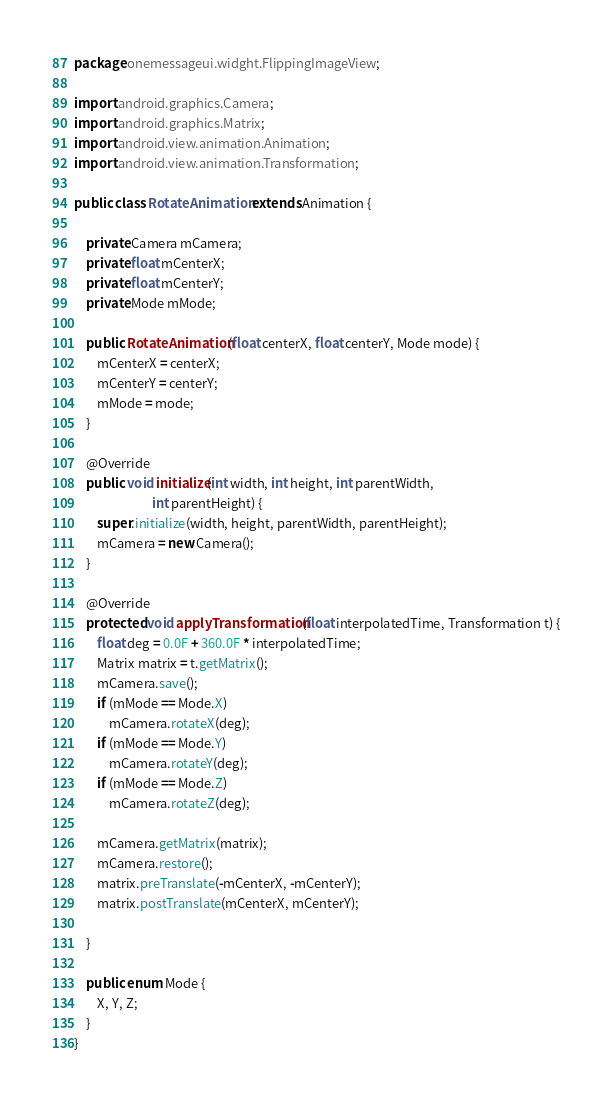Convert code to text. <code><loc_0><loc_0><loc_500><loc_500><_Java_>package onemessageui.widght.FlippingImageView;

import android.graphics.Camera;
import android.graphics.Matrix;
import android.view.animation.Animation;
import android.view.animation.Transformation;

public class RotateAnimation extends Animation {

    private Camera mCamera;
    private float mCenterX;
    private float mCenterY;
    private Mode mMode;

    public RotateAnimation(float centerX, float centerY, Mode mode) {
        mCenterX = centerX;
        mCenterY = centerY;
        mMode = mode;
    }

    @Override
    public void initialize(int width, int height, int parentWidth,
                           int parentHeight) {
        super.initialize(width, height, parentWidth, parentHeight);
        mCamera = new Camera();
    }

    @Override
    protected void applyTransformation(float interpolatedTime, Transformation t) {
        float deg = 0.0F + 360.0F * interpolatedTime;
        Matrix matrix = t.getMatrix();
        mCamera.save();
        if (mMode == Mode.X)
            mCamera.rotateX(deg);
        if (mMode == Mode.Y)
            mCamera.rotateY(deg);
        if (mMode == Mode.Z)
            mCamera.rotateZ(deg);

        mCamera.getMatrix(matrix);
        mCamera.restore();
        matrix.preTranslate(-mCenterX, -mCenterY);
        matrix.postTranslate(mCenterX, mCenterY);

    }

    public enum Mode {
        X, Y, Z;
    }
}
</code> 